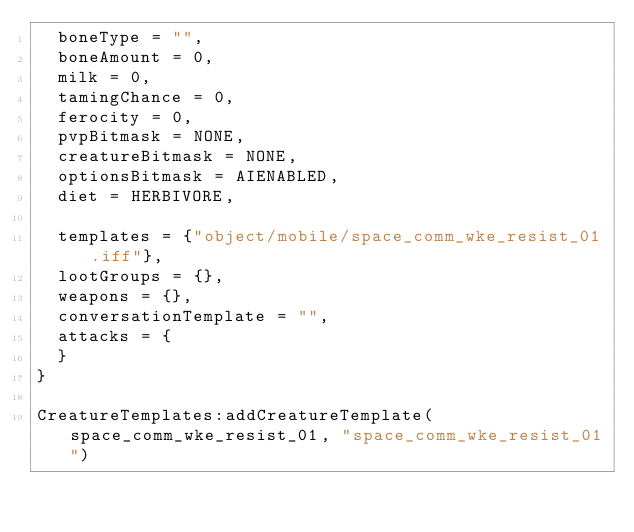<code> <loc_0><loc_0><loc_500><loc_500><_Lua_>	boneType = "",
	boneAmount = 0,
	milk = 0,
	tamingChance = 0,
	ferocity = 0,
	pvpBitmask = NONE,
	creatureBitmask = NONE,
	optionsBitmask = AIENABLED,
	diet = HERBIVORE,

	templates = {"object/mobile/space_comm_wke_resist_01.iff"},
	lootGroups = {},
	weapons = {},
	conversationTemplate = "",
	attacks = {
	}
}

CreatureTemplates:addCreatureTemplate(space_comm_wke_resist_01, "space_comm_wke_resist_01")
</code> 